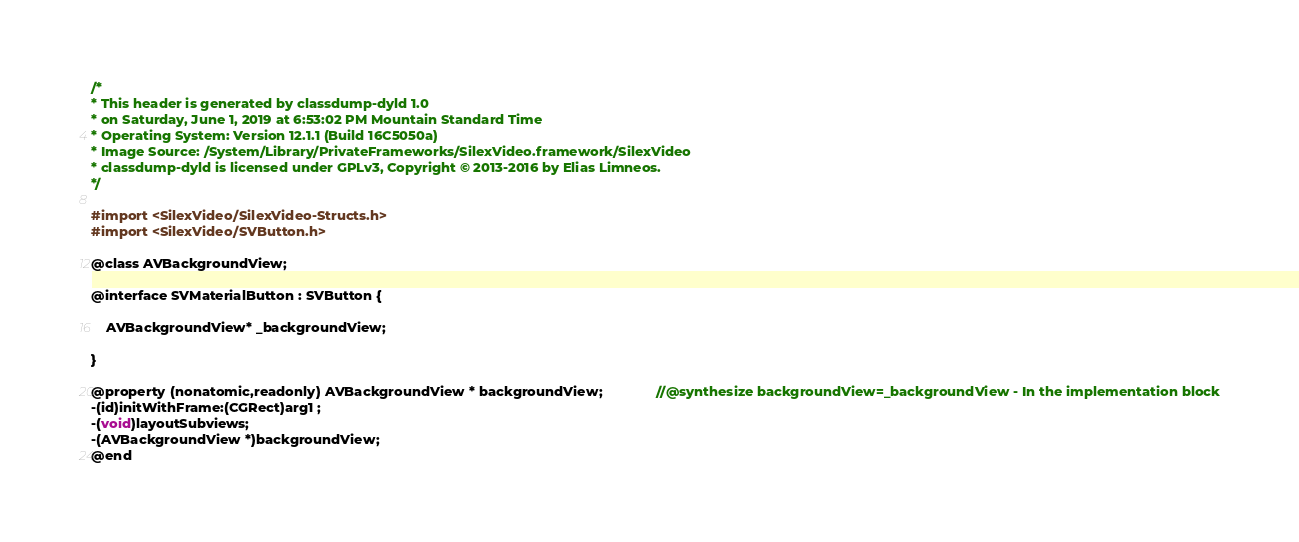Convert code to text. <code><loc_0><loc_0><loc_500><loc_500><_C_>/*
* This header is generated by classdump-dyld 1.0
* on Saturday, June 1, 2019 at 6:53:02 PM Mountain Standard Time
* Operating System: Version 12.1.1 (Build 16C5050a)
* Image Source: /System/Library/PrivateFrameworks/SilexVideo.framework/SilexVideo
* classdump-dyld is licensed under GPLv3, Copyright © 2013-2016 by Elias Limneos.
*/

#import <SilexVideo/SilexVideo-Structs.h>
#import <SilexVideo/SVButton.h>

@class AVBackgroundView;

@interface SVMaterialButton : SVButton {

	AVBackgroundView* _backgroundView;

}

@property (nonatomic,readonly) AVBackgroundView * backgroundView;              //@synthesize backgroundView=_backgroundView - In the implementation block
-(id)initWithFrame:(CGRect)arg1 ;
-(void)layoutSubviews;
-(AVBackgroundView *)backgroundView;
@end

</code> 